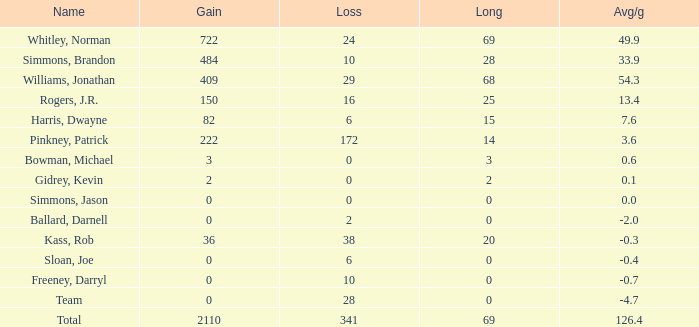What is the lowest Long, when Name is Kass, Rob, and when Avg/g is less than -0.30000000000000004? None. 